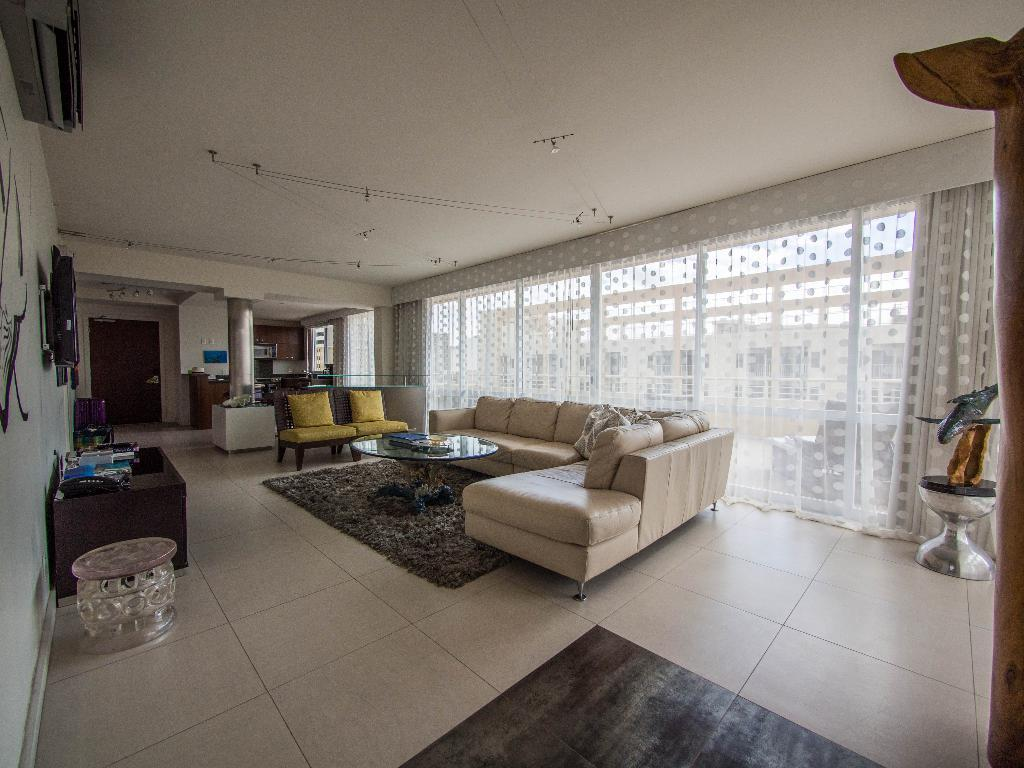What type of furniture is present in the image? There is a couch in the image. What can be seen on the couch? There is a pillow on the couch. What other piece of furniture is visible in the image? There is a table in the image. What architectural feature can be seen in the image? There is a door visible in the image. How many grapes are on the table in the image? There are no grapes present in the image. What type of power is being generated by the door in the image? There is no power generation associated with the door in the image. 